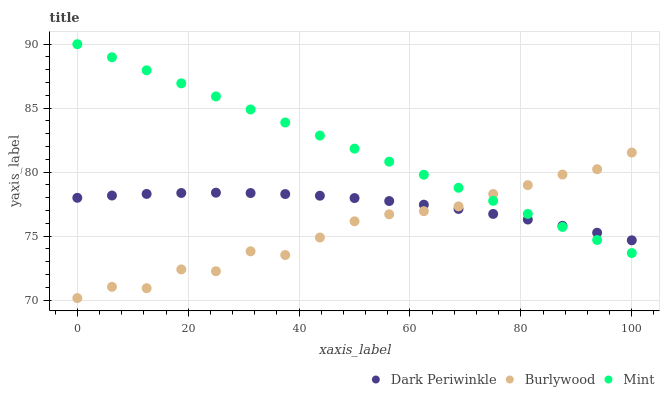Does Burlywood have the minimum area under the curve?
Answer yes or no. Yes. Does Mint have the maximum area under the curve?
Answer yes or no. Yes. Does Dark Periwinkle have the minimum area under the curve?
Answer yes or no. No. Does Dark Periwinkle have the maximum area under the curve?
Answer yes or no. No. Is Mint the smoothest?
Answer yes or no. Yes. Is Burlywood the roughest?
Answer yes or no. Yes. Is Dark Periwinkle the smoothest?
Answer yes or no. No. Is Dark Periwinkle the roughest?
Answer yes or no. No. Does Burlywood have the lowest value?
Answer yes or no. Yes. Does Mint have the lowest value?
Answer yes or no. No. Does Mint have the highest value?
Answer yes or no. Yes. Does Dark Periwinkle have the highest value?
Answer yes or no. No. Does Dark Periwinkle intersect Mint?
Answer yes or no. Yes. Is Dark Periwinkle less than Mint?
Answer yes or no. No. Is Dark Periwinkle greater than Mint?
Answer yes or no. No. 